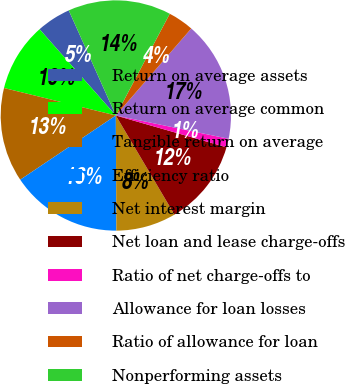Convert chart. <chart><loc_0><loc_0><loc_500><loc_500><pie_chart><fcel>Return on average assets<fcel>Return on average common<fcel>Tangible return on average<fcel>Efficiency ratio<fcel>Net interest margin<fcel>Net loan and lease charge-offs<fcel>Ratio of net charge-offs to<fcel>Allowance for loan losses<fcel>Ratio of allowance for loan<fcel>Nonperforming assets<nl><fcel>4.82%<fcel>9.64%<fcel>13.25%<fcel>15.66%<fcel>8.43%<fcel>12.05%<fcel>1.21%<fcel>16.87%<fcel>3.61%<fcel>14.46%<nl></chart> 